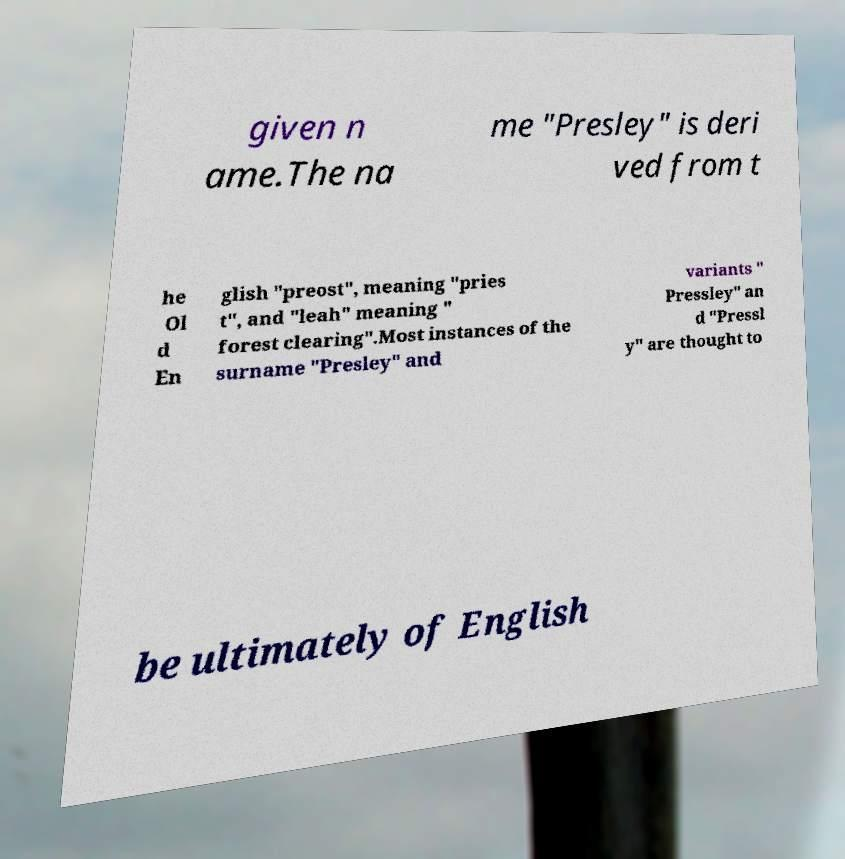What messages or text are displayed in this image? I need them in a readable, typed format. given n ame.The na me "Presley" is deri ved from t he Ol d En glish "preost", meaning "pries t", and "leah" meaning " forest clearing".Most instances of the surname "Presley" and variants " Pressley" an d "Pressl y" are thought to be ultimately of English 